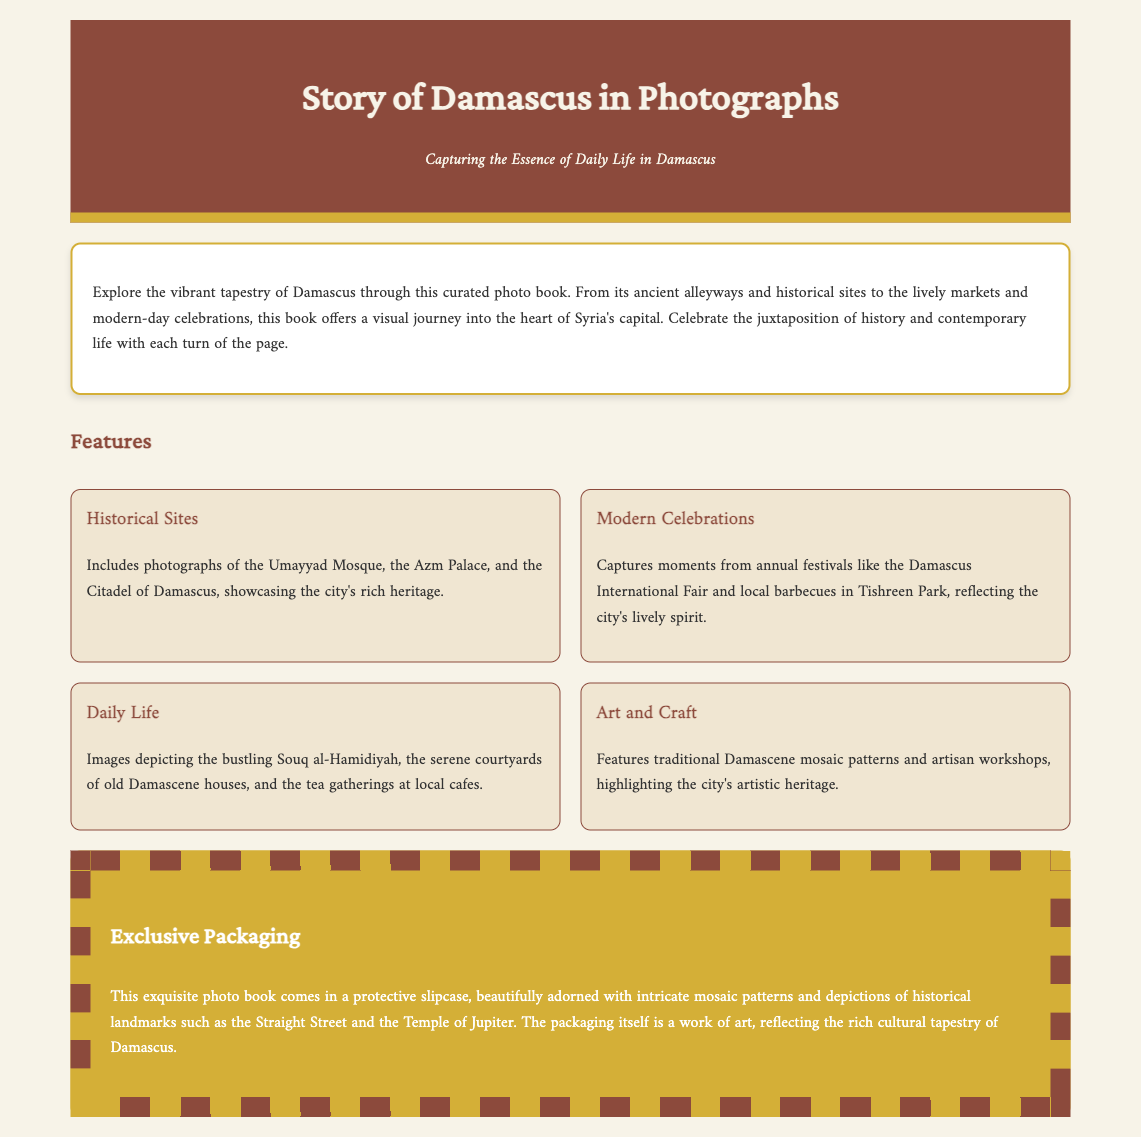what is the title of the photo book? The title is prominently displayed in the header of the document as "Story of Damascus in Photographs."
Answer: Story of Damascus in Photographs what type of packaging does the book come in? The document describes the packaging as a "protective slipcase."
Answer: protective slipcase which historical site is mentioned first? The first historical site listed in the features section is the "Umayyad Mosque."
Answer: Umayyad Mosque how many features are listed in the photo book? There are four features mentioned in the document, detailed in the features section.
Answer: four what is depicted on the packaging? The packaging features "intricate mosaic patterns and depictions of historical landmarks."
Answer: intricate mosaic patterns and depictions of historical landmarks which modern celebration is highlighted in the features section? The document specifically mentions the "Damascus International Fair" as a modern celebration.
Answer: Damascus International Fair what is the background color of the document? The background color specified in the styles is "#f7f3e8".
Answer: #f7f3e8 what artistic heritage is emphasized in the photo book? The feature related to art and craft highlights "traditional Damascene mosaic patterns."
Answer: traditional Damascene mosaic patterns what type of life is portrayed in the photo book? The book portrays the "essence of daily life in Damascus."
Answer: essence of daily life in Damascus 